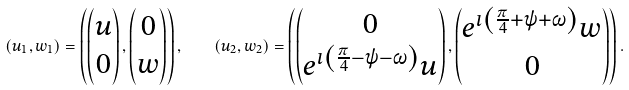<formula> <loc_0><loc_0><loc_500><loc_500>( u _ { 1 } , w _ { 1 } ) = \left ( \begin{pmatrix} u \\ 0 \end{pmatrix} , \begin{pmatrix} 0 \\ w \end{pmatrix} \right ) , \quad ( u _ { 2 } , w _ { 2 } ) = \left ( \begin{pmatrix} 0 \\ e ^ { \imath \left ( \frac { \pi } { 4 } - \psi - \omega \right ) } u \end{pmatrix} , \begin{pmatrix} e ^ { \imath \left ( \frac { \pi } { 4 } + \psi + \omega \right ) } w \\ 0 \end{pmatrix} \right ) .</formula> 